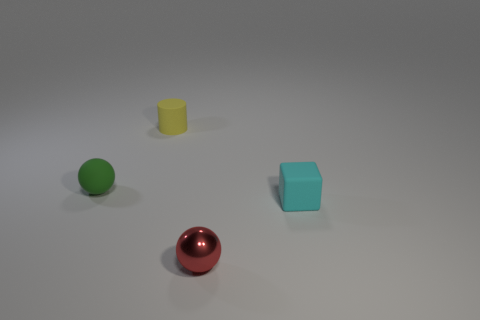How many balls are on the right side of the ball behind the matte thing that is in front of the green object?
Provide a succinct answer. 1. What number of spheres are yellow rubber objects or green rubber things?
Your answer should be compact. 1. There is a small sphere in front of the tiny thing left of the yellow cylinder that is behind the small matte cube; what color is it?
Your response must be concise. Red. How many other objects are the same size as the red shiny sphere?
Keep it short and to the point. 3. Is there anything else that is the same shape as the tiny red shiny object?
Give a very brief answer. Yes. There is another rubber thing that is the same shape as the tiny red thing; what is its color?
Offer a terse response. Green. What color is the tiny cylinder that is the same material as the small cyan thing?
Offer a terse response. Yellow. Are there the same number of small cyan rubber things behind the tiny cyan rubber block and matte cylinders?
Your answer should be very brief. No. Does the yellow rubber object left of the red ball have the same size as the tiny rubber cube?
Your response must be concise. Yes. There is a cylinder that is the same size as the green matte ball; what is its color?
Offer a terse response. Yellow. 